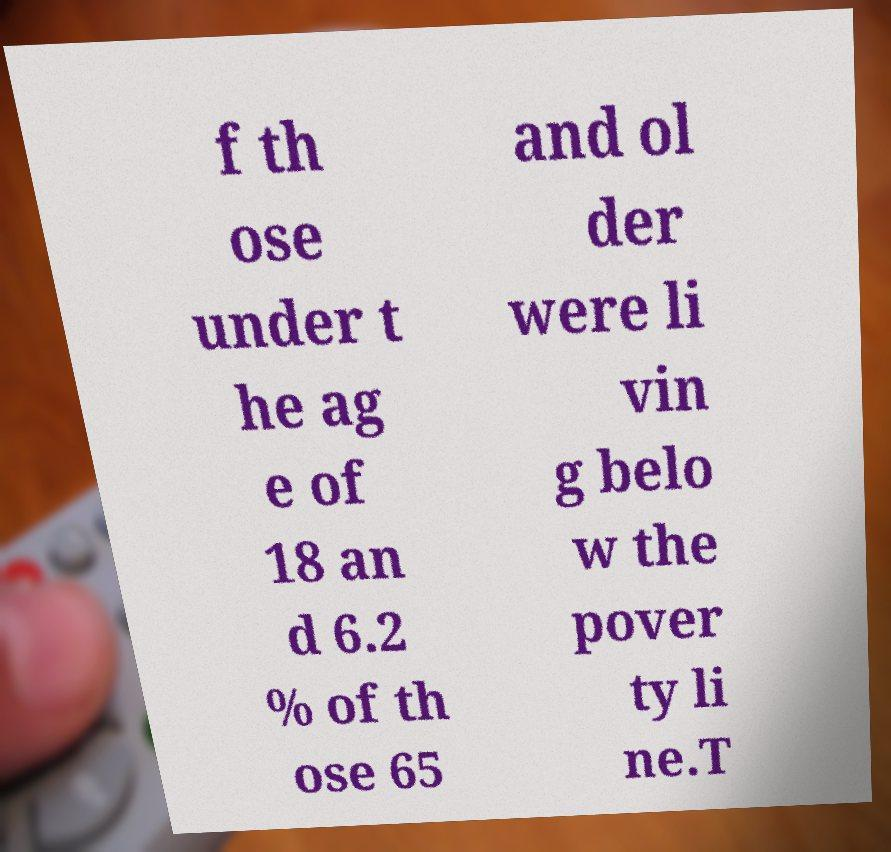What messages or text are displayed in this image? I need them in a readable, typed format. f th ose under t he ag e of 18 an d 6.2 % of th ose 65 and ol der were li vin g belo w the pover ty li ne.T 